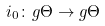<formula> <loc_0><loc_0><loc_500><loc_500>i _ { 0 } \colon g \Theta \to g \Theta</formula> 